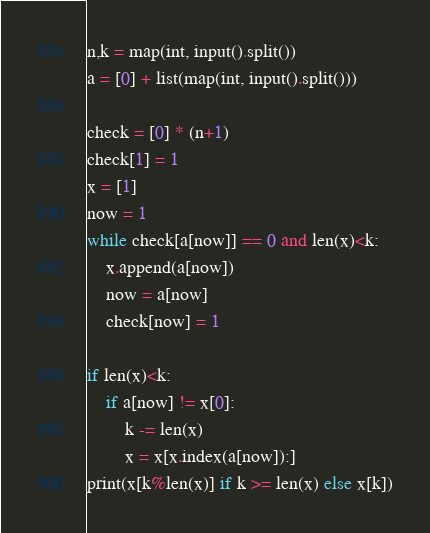Convert code to text. <code><loc_0><loc_0><loc_500><loc_500><_Python_>n,k = map(int, input().split())
a = [0] + list(map(int, input().split()))

check = [0] * (n+1)
check[1] = 1
x = [1]
now = 1
while check[a[now]] == 0 and len(x)<k:
    x.append(a[now])
    now = a[now]
    check[now] = 1

if len(x)<k:
    if a[now] != x[0]: 
        k -= len(x)
        x = x[x.index(a[now]):]
print(x[k%len(x)] if k >= len(x) else x[k])</code> 